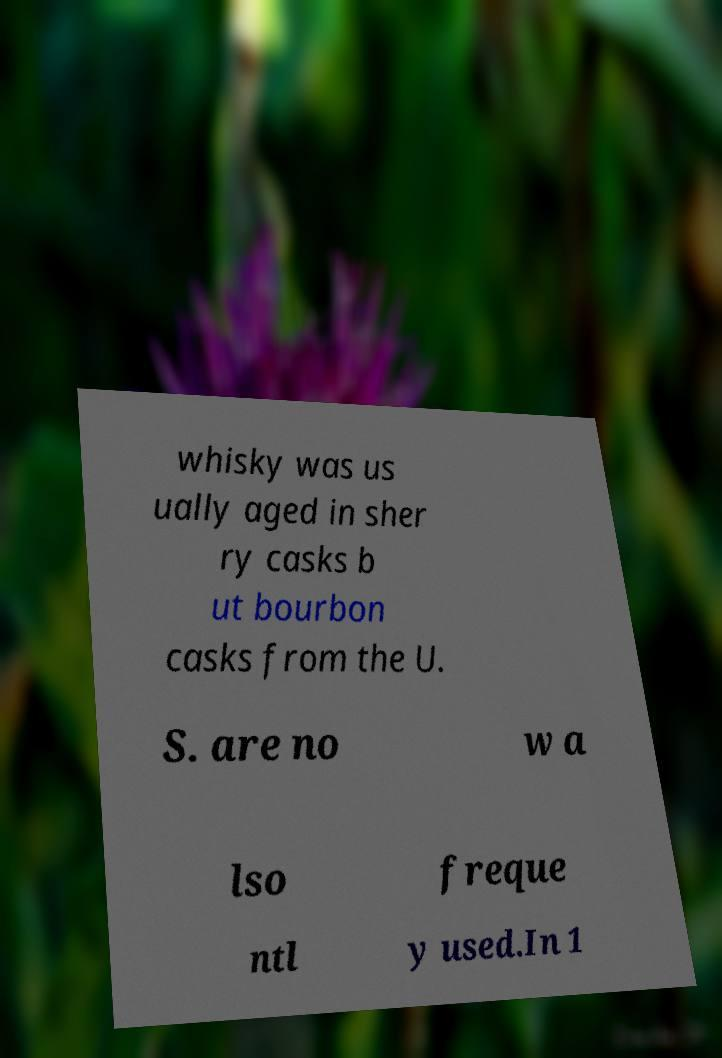Please identify and transcribe the text found in this image. whisky was us ually aged in sher ry casks b ut bourbon casks from the U. S. are no w a lso freque ntl y used.In 1 